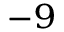<formula> <loc_0><loc_0><loc_500><loc_500>^ { - 9 }</formula> 